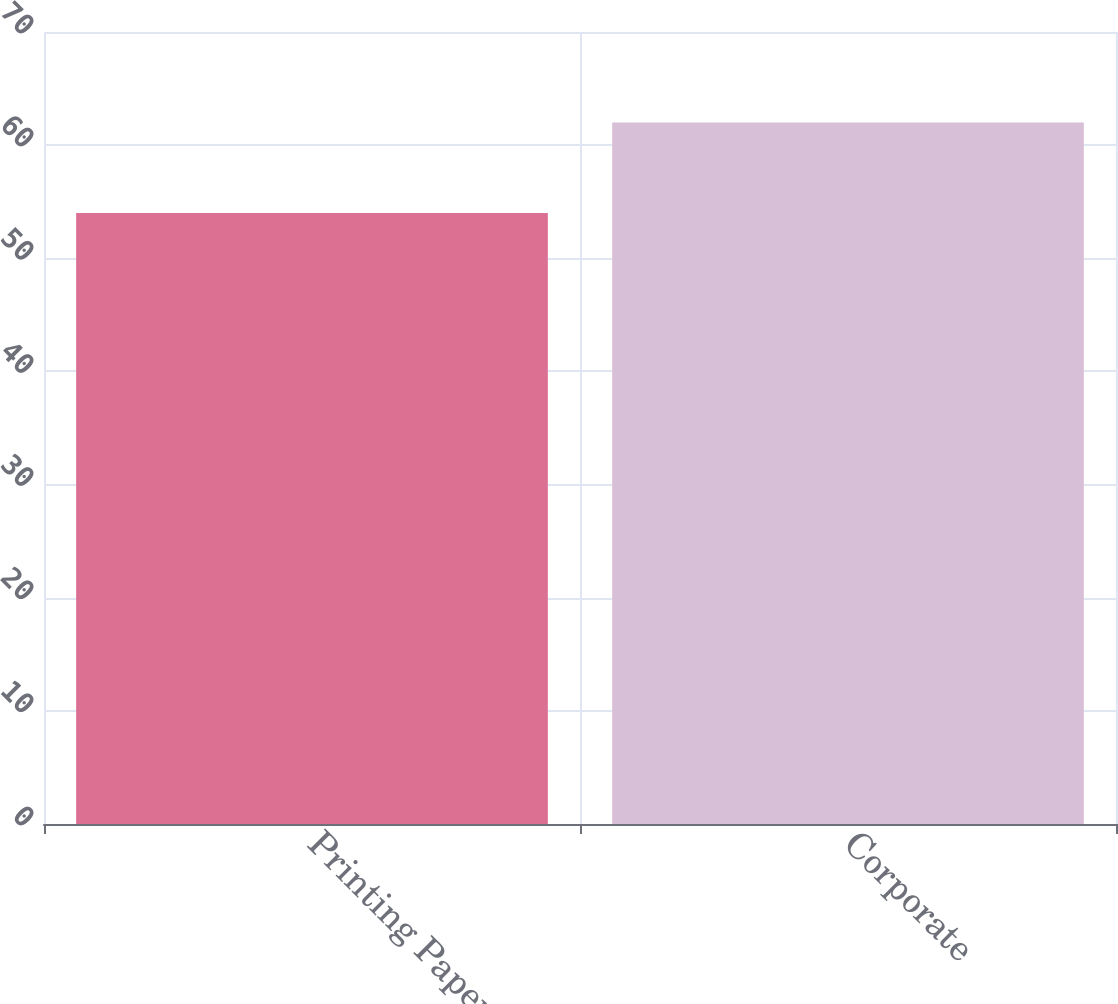Convert chart to OTSL. <chart><loc_0><loc_0><loc_500><loc_500><bar_chart><fcel>Printing Papers<fcel>Corporate<nl><fcel>54<fcel>62<nl></chart> 